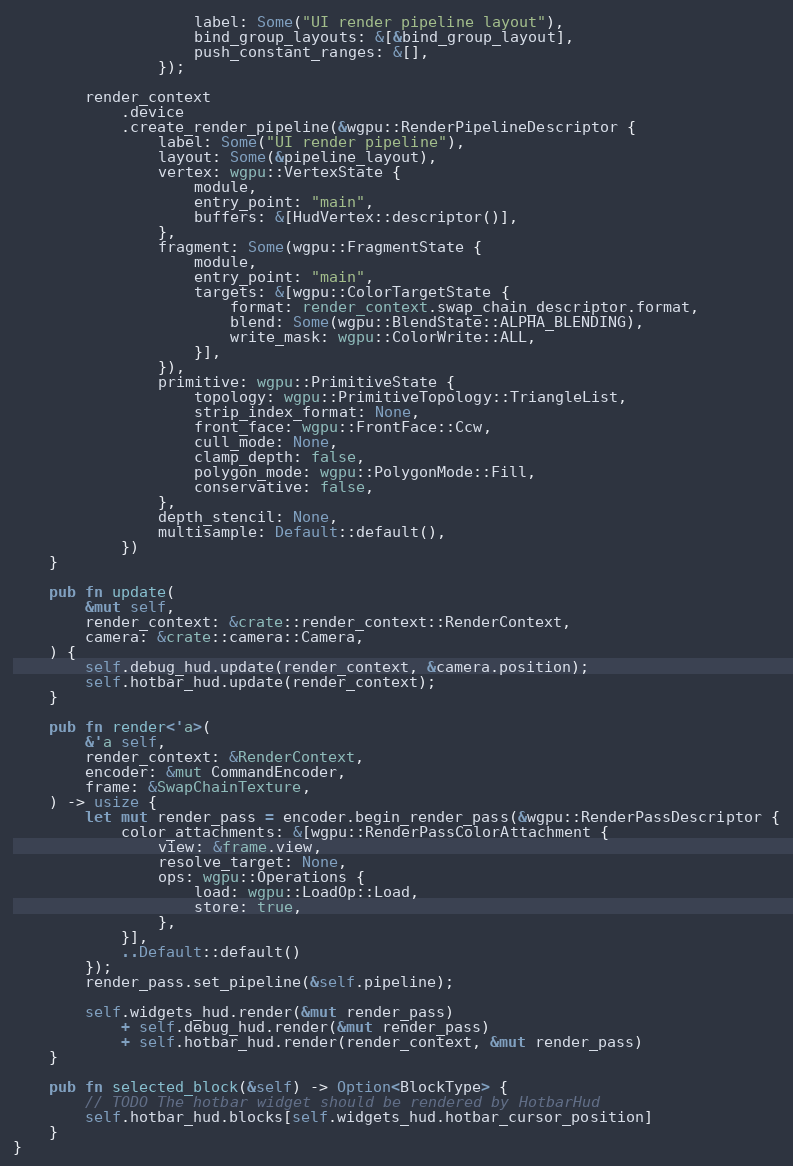<code> <loc_0><loc_0><loc_500><loc_500><_Rust_>                    label: Some("UI render pipeline layout"),
                    bind_group_layouts: &[&bind_group_layout],
                    push_constant_ranges: &[],
                });

        render_context
            .device
            .create_render_pipeline(&wgpu::RenderPipelineDescriptor {
                label: Some("UI render pipeline"),
                layout: Some(&pipeline_layout),
                vertex: wgpu::VertexState {
                    module,
                    entry_point: "main",
                    buffers: &[HudVertex::descriptor()],
                },
                fragment: Some(wgpu::FragmentState {
                    module,
                    entry_point: "main",
                    targets: &[wgpu::ColorTargetState {
                        format: render_context.swap_chain_descriptor.format,
                        blend: Some(wgpu::BlendState::ALPHA_BLENDING),
                        write_mask: wgpu::ColorWrite::ALL,
                    }],
                }),
                primitive: wgpu::PrimitiveState {
                    topology: wgpu::PrimitiveTopology::TriangleList,
                    strip_index_format: None,
                    front_face: wgpu::FrontFace::Ccw,
                    cull_mode: None,
                    clamp_depth: false,
                    polygon_mode: wgpu::PolygonMode::Fill,
                    conservative: false,
                },
                depth_stencil: None,
                multisample: Default::default(),
            })
    }

    pub fn update(
        &mut self,
        render_context: &crate::render_context::RenderContext,
        camera: &crate::camera::Camera,
    ) {
        self.debug_hud.update(render_context, &camera.position);
        self.hotbar_hud.update(render_context);
    }

    pub fn render<'a>(
        &'a self,
        render_context: &RenderContext,
        encoder: &mut CommandEncoder,
        frame: &SwapChainTexture,
    ) -> usize {
        let mut render_pass = encoder.begin_render_pass(&wgpu::RenderPassDescriptor {
            color_attachments: &[wgpu::RenderPassColorAttachment {
                view: &frame.view,
                resolve_target: None,
                ops: wgpu::Operations {
                    load: wgpu::LoadOp::Load,
                    store: true,
                },
            }],
            ..Default::default()
        });
        render_pass.set_pipeline(&self.pipeline);

        self.widgets_hud.render(&mut render_pass)
            + self.debug_hud.render(&mut render_pass)
            + self.hotbar_hud.render(render_context, &mut render_pass)
    }

    pub fn selected_block(&self) -> Option<BlockType> {
        // TODO The hotbar widget should be rendered by HotbarHud
        self.hotbar_hud.blocks[self.widgets_hud.hotbar_cursor_position]
    }
}
</code> 